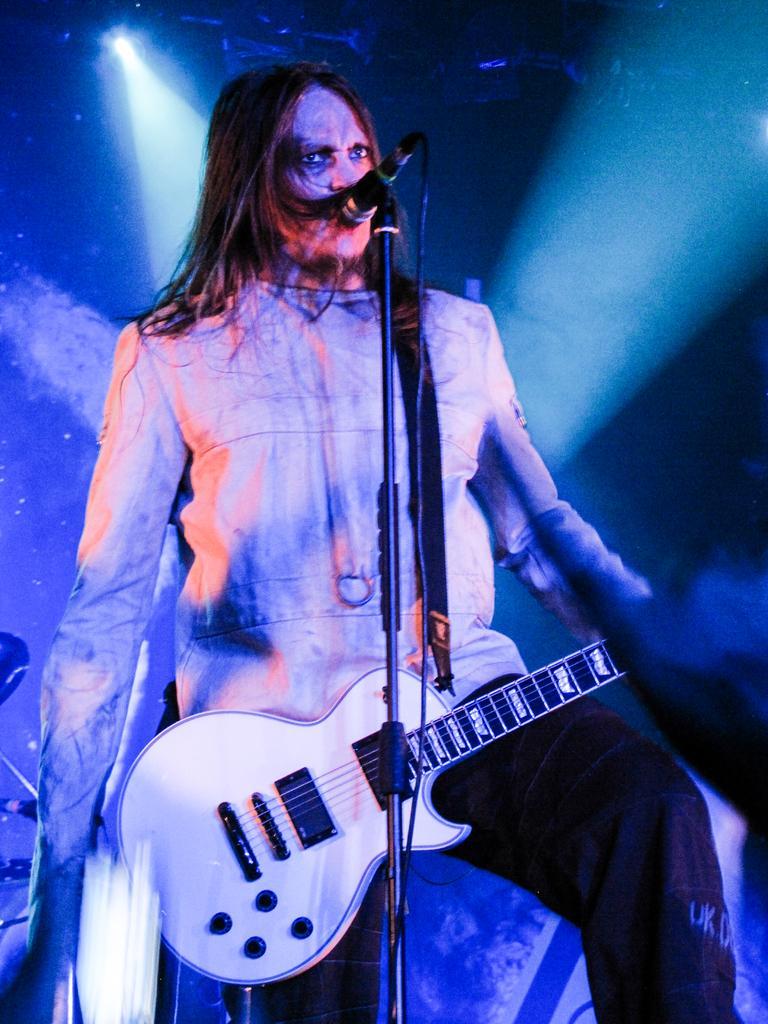Can you describe this image briefly? In this image the person is standing and holding a guitar. There is a mic and stand. 